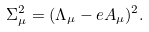Convert formula to latex. <formula><loc_0><loc_0><loc_500><loc_500>\Sigma _ { \mu } ^ { 2 } = ( \Lambda _ { \mu } - e A _ { \mu } ) ^ { 2 } .</formula> 